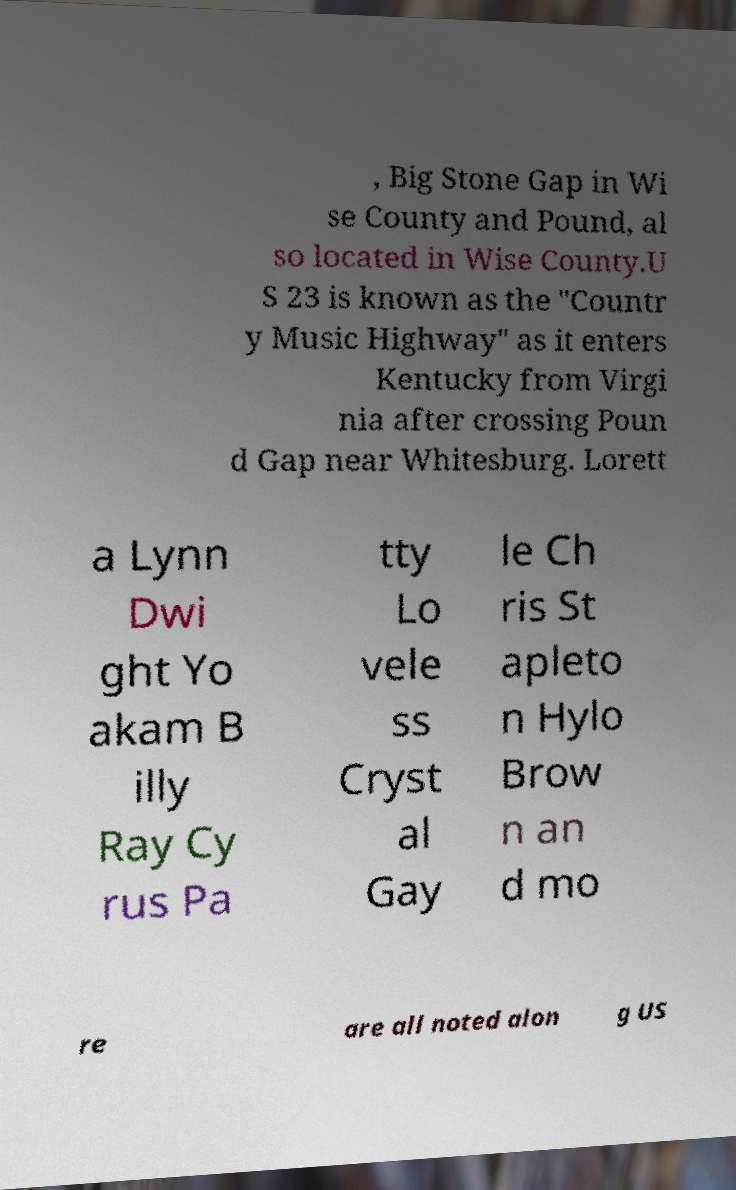Please identify and transcribe the text found in this image. , Big Stone Gap in Wi se County and Pound, al so located in Wise County.U S 23 is known as the "Countr y Music Highway" as it enters Kentucky from Virgi nia after crossing Poun d Gap near Whitesburg. Lorett a Lynn Dwi ght Yo akam B illy Ray Cy rus Pa tty Lo vele ss Cryst al Gay le Ch ris St apleto n Hylo Brow n an d mo re are all noted alon g US 